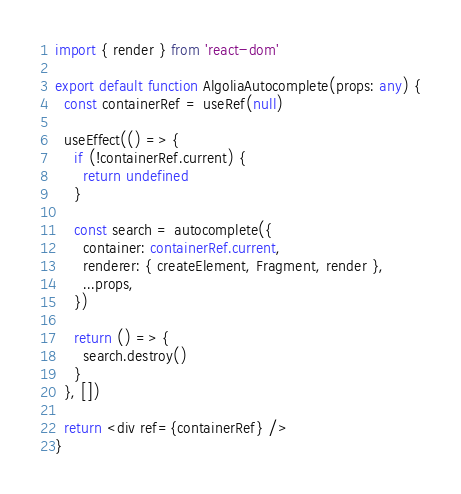Convert code to text. <code><loc_0><loc_0><loc_500><loc_500><_TypeScript_>import { render } from 'react-dom'

export default function AlgoliaAutocomplete(props: any) {
  const containerRef = useRef(null)

  useEffect(() => {
    if (!containerRef.current) {
      return undefined
    }

    const search = autocomplete({
      container: containerRef.current,
      renderer: { createElement, Fragment, render },
      ...props,
    })

    return () => {
      search.destroy()
    }
  }, [])

  return <div ref={containerRef} />
}
</code> 